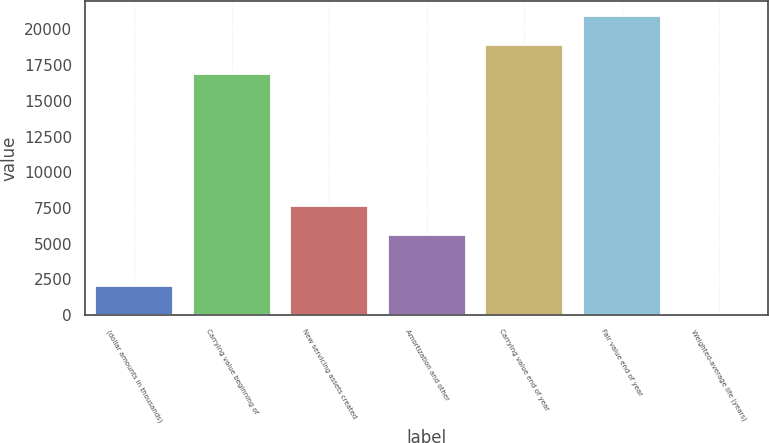Convert chart. <chart><loc_0><loc_0><loc_500><loc_500><bar_chart><fcel>(dollar amounts in thousands)<fcel>Carrying value beginning of<fcel>New servicing assets created<fcel>Amortization and other<fcel>Carrying value end of year<fcel>Fair value end of year<fcel>Weighted-average life (years)<nl><fcel>2052.65<fcel>16865<fcel>7647.15<fcel>5598<fcel>18914.2<fcel>20963.3<fcel>3.5<nl></chart> 